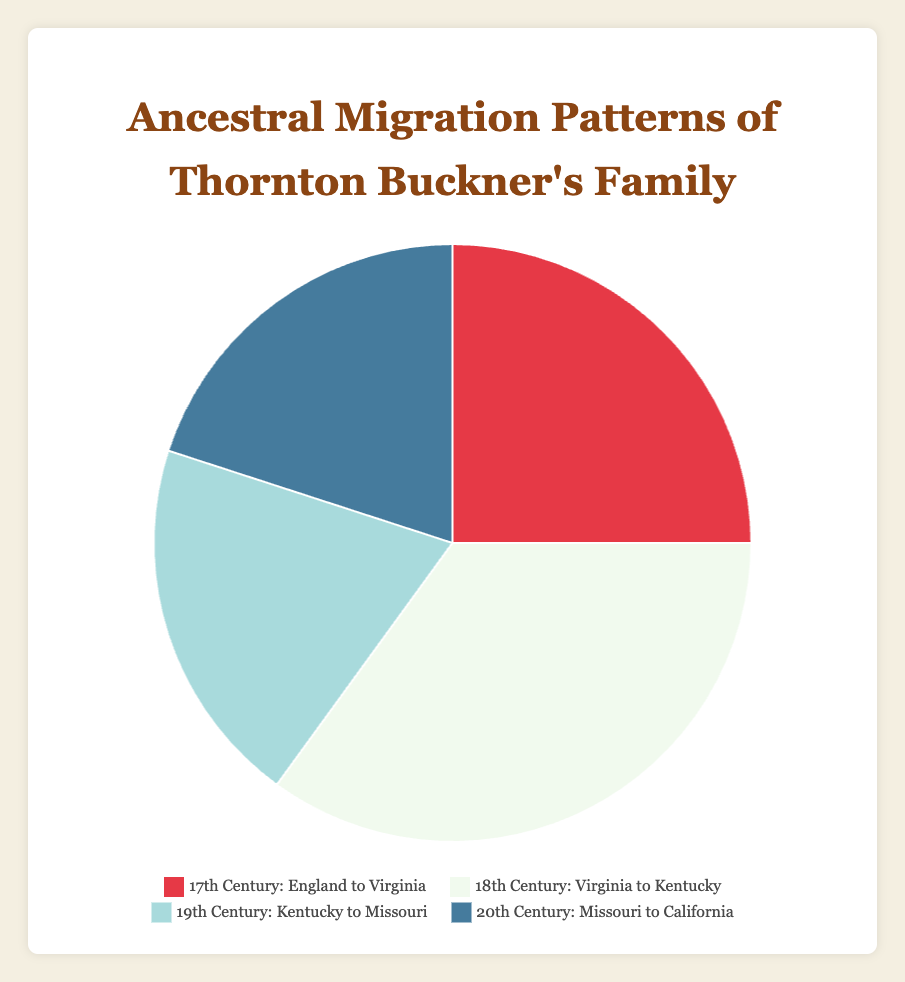Which century has the highest percentage of migration? By looking at the pie chart, the largest segment corresponds to "18th Century: Virginia to Kentucky." The legend also states that this segment accounts for 35% of the total.
Answer: 18th Century Which migration pattern represents the smallest percentage? The two smallest percentages on the pie chart are equal, and both correspond to the 19th Century: "Kentucky to Missouri" and the 20th Century: "Missouri to California," each with 20%.
Answer: 19th and 20th Century What is the combined percentage of migration from the 17th and 19th centuries? The 17th Century segment accounts for 25%, and the 19th Century segment accounts for 20%. Adding these percentages together: 25% + 20% = 45%.
Answer: 45% Is the percentage of migration in the 20th Century less than that of the 18th Century? The pie chart shows that the 18th Century accounts for 35%, while the 20th Century accounts for 20%. Since 20% is less than 35%, the answer is yes.
Answer: Yes How many percentage points more is the 18th Century migration compared to the 17th Century migration? The 18th Century has 35% and the 17th Century has 25%. The difference in percentage points is 35% - 25% = 10%.
Answer: 10% What is the average percentage of migration across all four centuries? To find the average, sum up all percentages and divide by the number of data points: (25% + 35% + 20% + 20%) / 4 = 100% / 4 = 25%.
Answer: 25% Which century has a red color associated with its migration pattern? The legend indicates that the red color is associated with the 17th Century: "England to Virginia."
Answer: 17th Century Are the percentages of migration in the 19th and 20th centuries equal? Both the 19th and 20th Centuries segments in the pie chart indicate a migration percentage of 20%.
Answer: Yes What percentage of migrations occurred before the 19th Century? Summing the percentages of the 17th and 18th Centuries gives: 25% + 35% = 60%.
Answer: 60% Compare the 19th Century migration percentage to the overall total percentage. Is it greater than, less than, or equal to 1/4 of the total migration? The 19th Century accounts for 20%. One-fourth of the total migration (100%) is 25%. Since 20% is less than 25%, the 19th Century percentage is less than 1/4 of the total.
Answer: Less than 1/4 